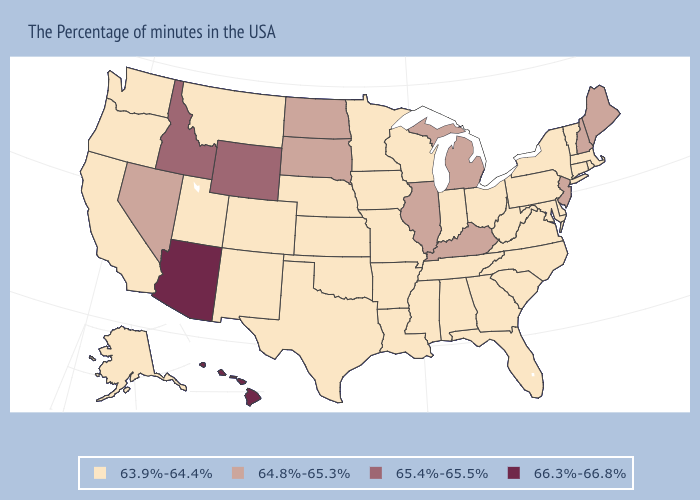Is the legend a continuous bar?
Be succinct. No. What is the value of Nebraska?
Answer briefly. 63.9%-64.4%. Does Hawaii have the highest value in the USA?
Write a very short answer. Yes. Does the map have missing data?
Give a very brief answer. No. Name the states that have a value in the range 66.3%-66.8%?
Keep it brief. Arizona, Hawaii. Which states hav the highest value in the West?
Give a very brief answer. Arizona, Hawaii. Does the first symbol in the legend represent the smallest category?
Keep it brief. Yes. What is the value of Colorado?
Keep it brief. 63.9%-64.4%. What is the value of Maryland?
Quick response, please. 63.9%-64.4%. What is the highest value in the MidWest ?
Write a very short answer. 64.8%-65.3%. Does Washington have the highest value in the West?
Be succinct. No. What is the value of Texas?
Write a very short answer. 63.9%-64.4%. What is the value of Connecticut?
Keep it brief. 63.9%-64.4%. Name the states that have a value in the range 65.4%-65.5%?
Be succinct. Wyoming, Idaho. What is the value of Utah?
Quick response, please. 63.9%-64.4%. 